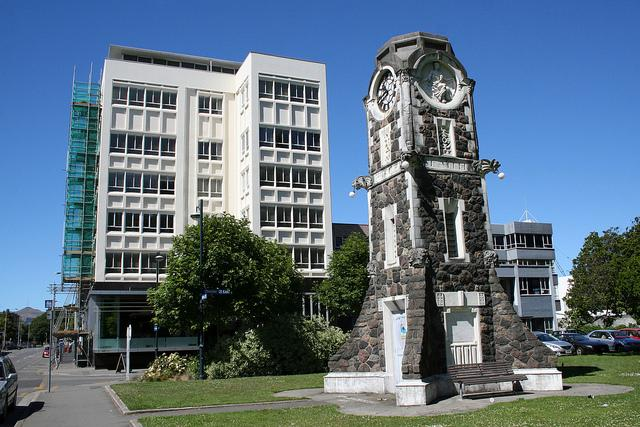How do you know there is work being done on the white building? Please explain your reasoning. scaffolding. When construction is being completed on a building sometimes a temporary structure is put up to support people and supplies in otherwise hard to reach areas. 